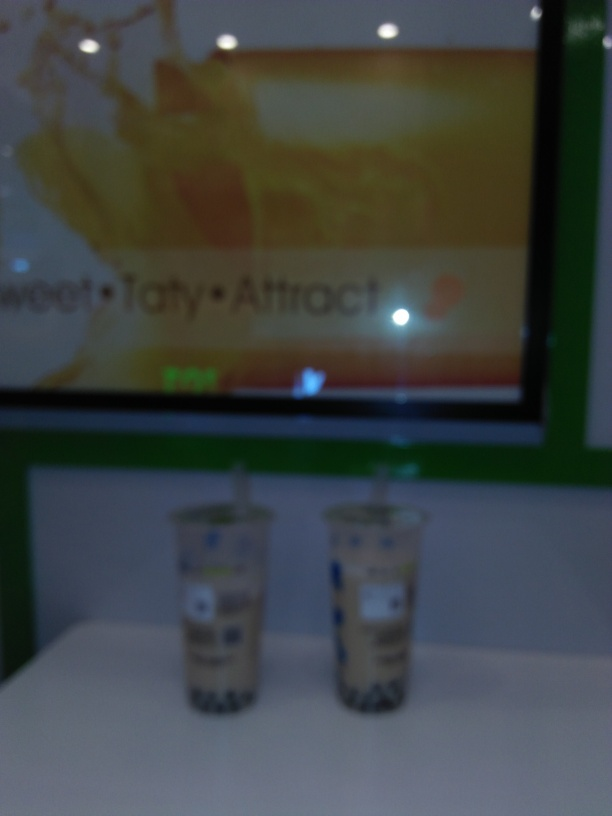What kind of beverages are shown in the image? The image displays two cups of a beverage, which appear to be a form of milk tea or a similarly creamy iced drink, often accompanied by toppings like tapioca pearls. 